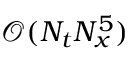Convert formula to latex. <formula><loc_0><loc_0><loc_500><loc_500>\mathcal { O } ( N _ { t } N _ { x } ^ { 5 } )</formula> 